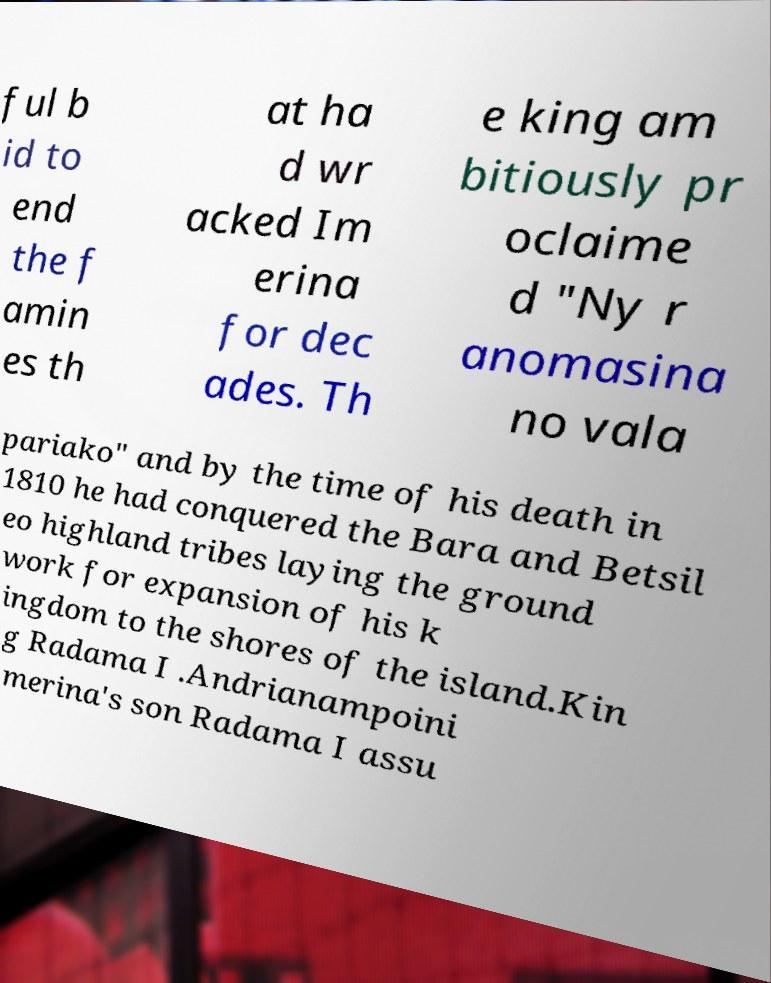What messages or text are displayed in this image? I need them in a readable, typed format. ful b id to end the f amin es th at ha d wr acked Im erina for dec ades. Th e king am bitiously pr oclaime d "Ny r anomasina no vala pariako" and by the time of his death in 1810 he had conquered the Bara and Betsil eo highland tribes laying the ground work for expansion of his k ingdom to the shores of the island.Kin g Radama I .Andrianampoini merina's son Radama I assu 